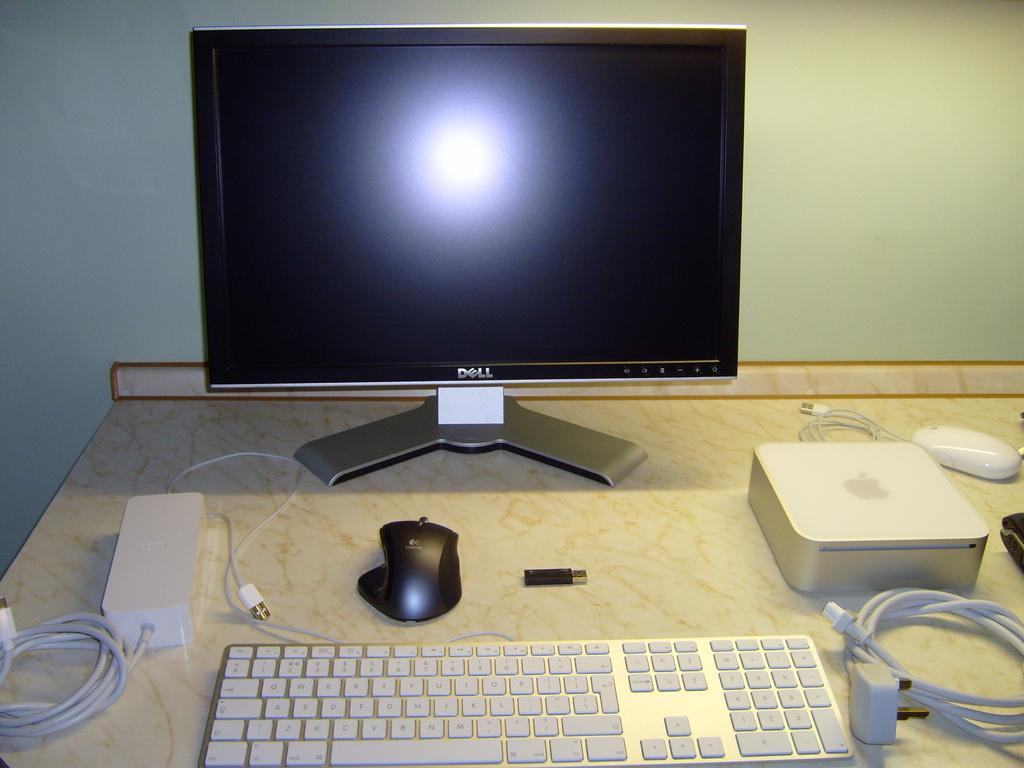What type of furniture is in the image? There is a table in the image. What electronic device is on the table? A monitor is present on the table. What input device is on the table? A keyboard is on the table. How many mouses are on the table? There are mouses on the table. What type of storage device is visible on the table? A pen drive is visible on the table. What type of wires are present on the table? Cable wires are present on the table. What type of power converters are on the table? Adapters are on the table. What can be seen in the background of the image? There is a wall visible in the image. What type of light can be seen emanating from the pen drive in the image? There is no light emanating from the pen drive in the image; it is a storage device and does not produce light. 